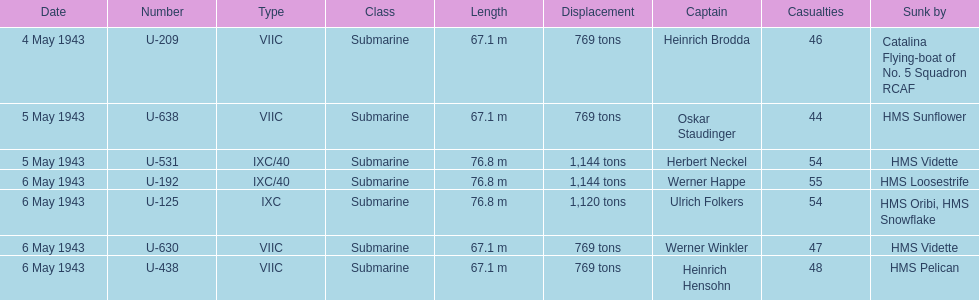Which sunken u-boat had the most casualties U-192. 